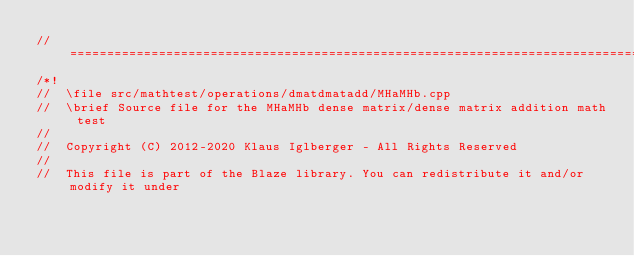Convert code to text. <code><loc_0><loc_0><loc_500><loc_500><_C++_>//=================================================================================================
/*!
//  \file src/mathtest/operations/dmatdmatadd/MHaMHb.cpp
//  \brief Source file for the MHaMHb dense matrix/dense matrix addition math test
//
//  Copyright (C) 2012-2020 Klaus Iglberger - All Rights Reserved
//
//  This file is part of the Blaze library. You can redistribute it and/or modify it under</code> 